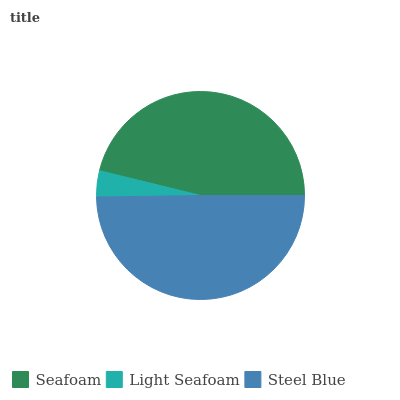Is Light Seafoam the minimum?
Answer yes or no. Yes. Is Steel Blue the maximum?
Answer yes or no. Yes. Is Steel Blue the minimum?
Answer yes or no. No. Is Light Seafoam the maximum?
Answer yes or no. No. Is Steel Blue greater than Light Seafoam?
Answer yes or no. Yes. Is Light Seafoam less than Steel Blue?
Answer yes or no. Yes. Is Light Seafoam greater than Steel Blue?
Answer yes or no. No. Is Steel Blue less than Light Seafoam?
Answer yes or no. No. Is Seafoam the high median?
Answer yes or no. Yes. Is Seafoam the low median?
Answer yes or no. Yes. Is Steel Blue the high median?
Answer yes or no. No. Is Steel Blue the low median?
Answer yes or no. No. 